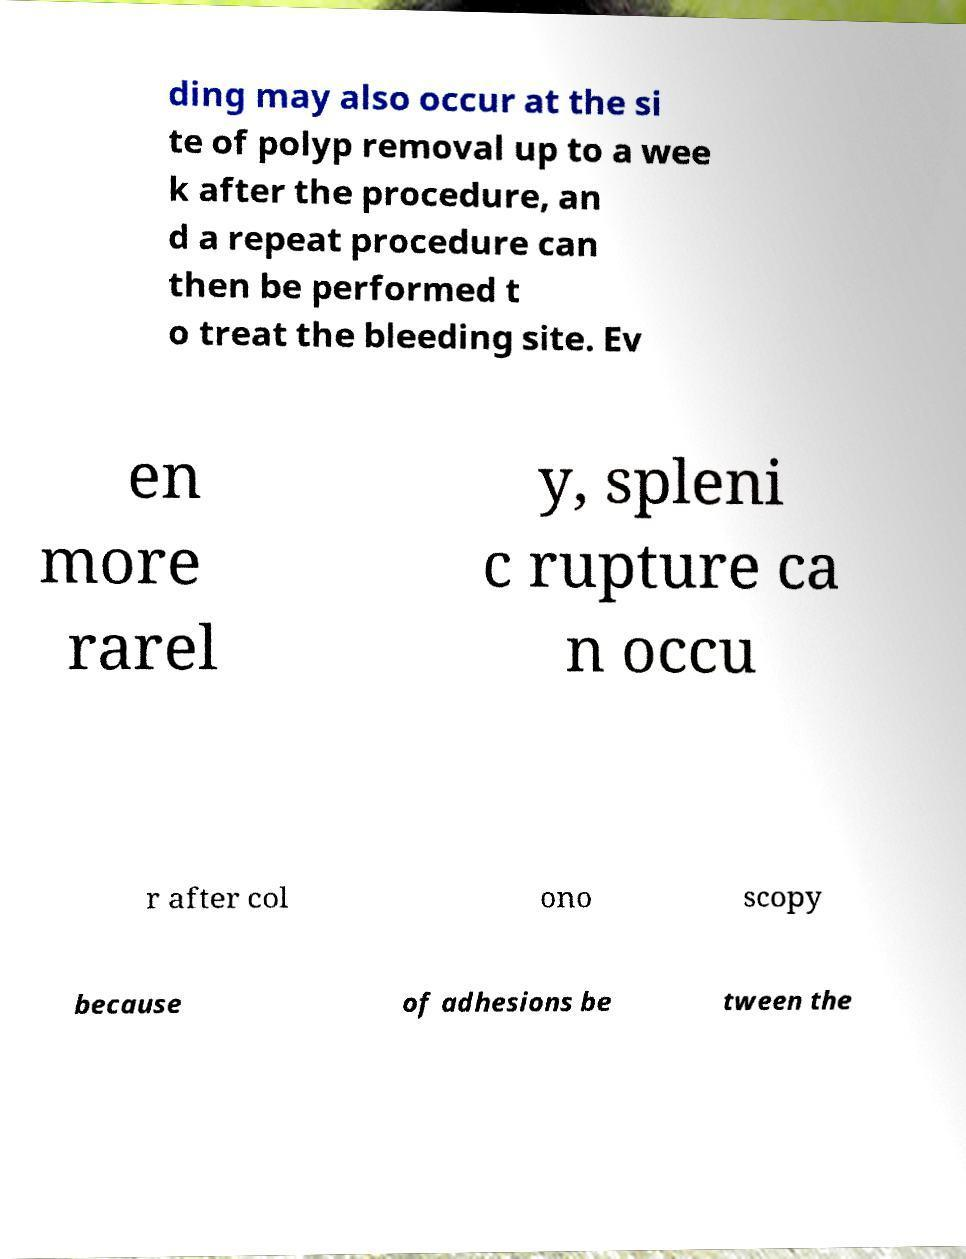Can you accurately transcribe the text from the provided image for me? ding may also occur at the si te of polyp removal up to a wee k after the procedure, an d a repeat procedure can then be performed t o treat the bleeding site. Ev en more rarel y, spleni c rupture ca n occu r after col ono scopy because of adhesions be tween the 